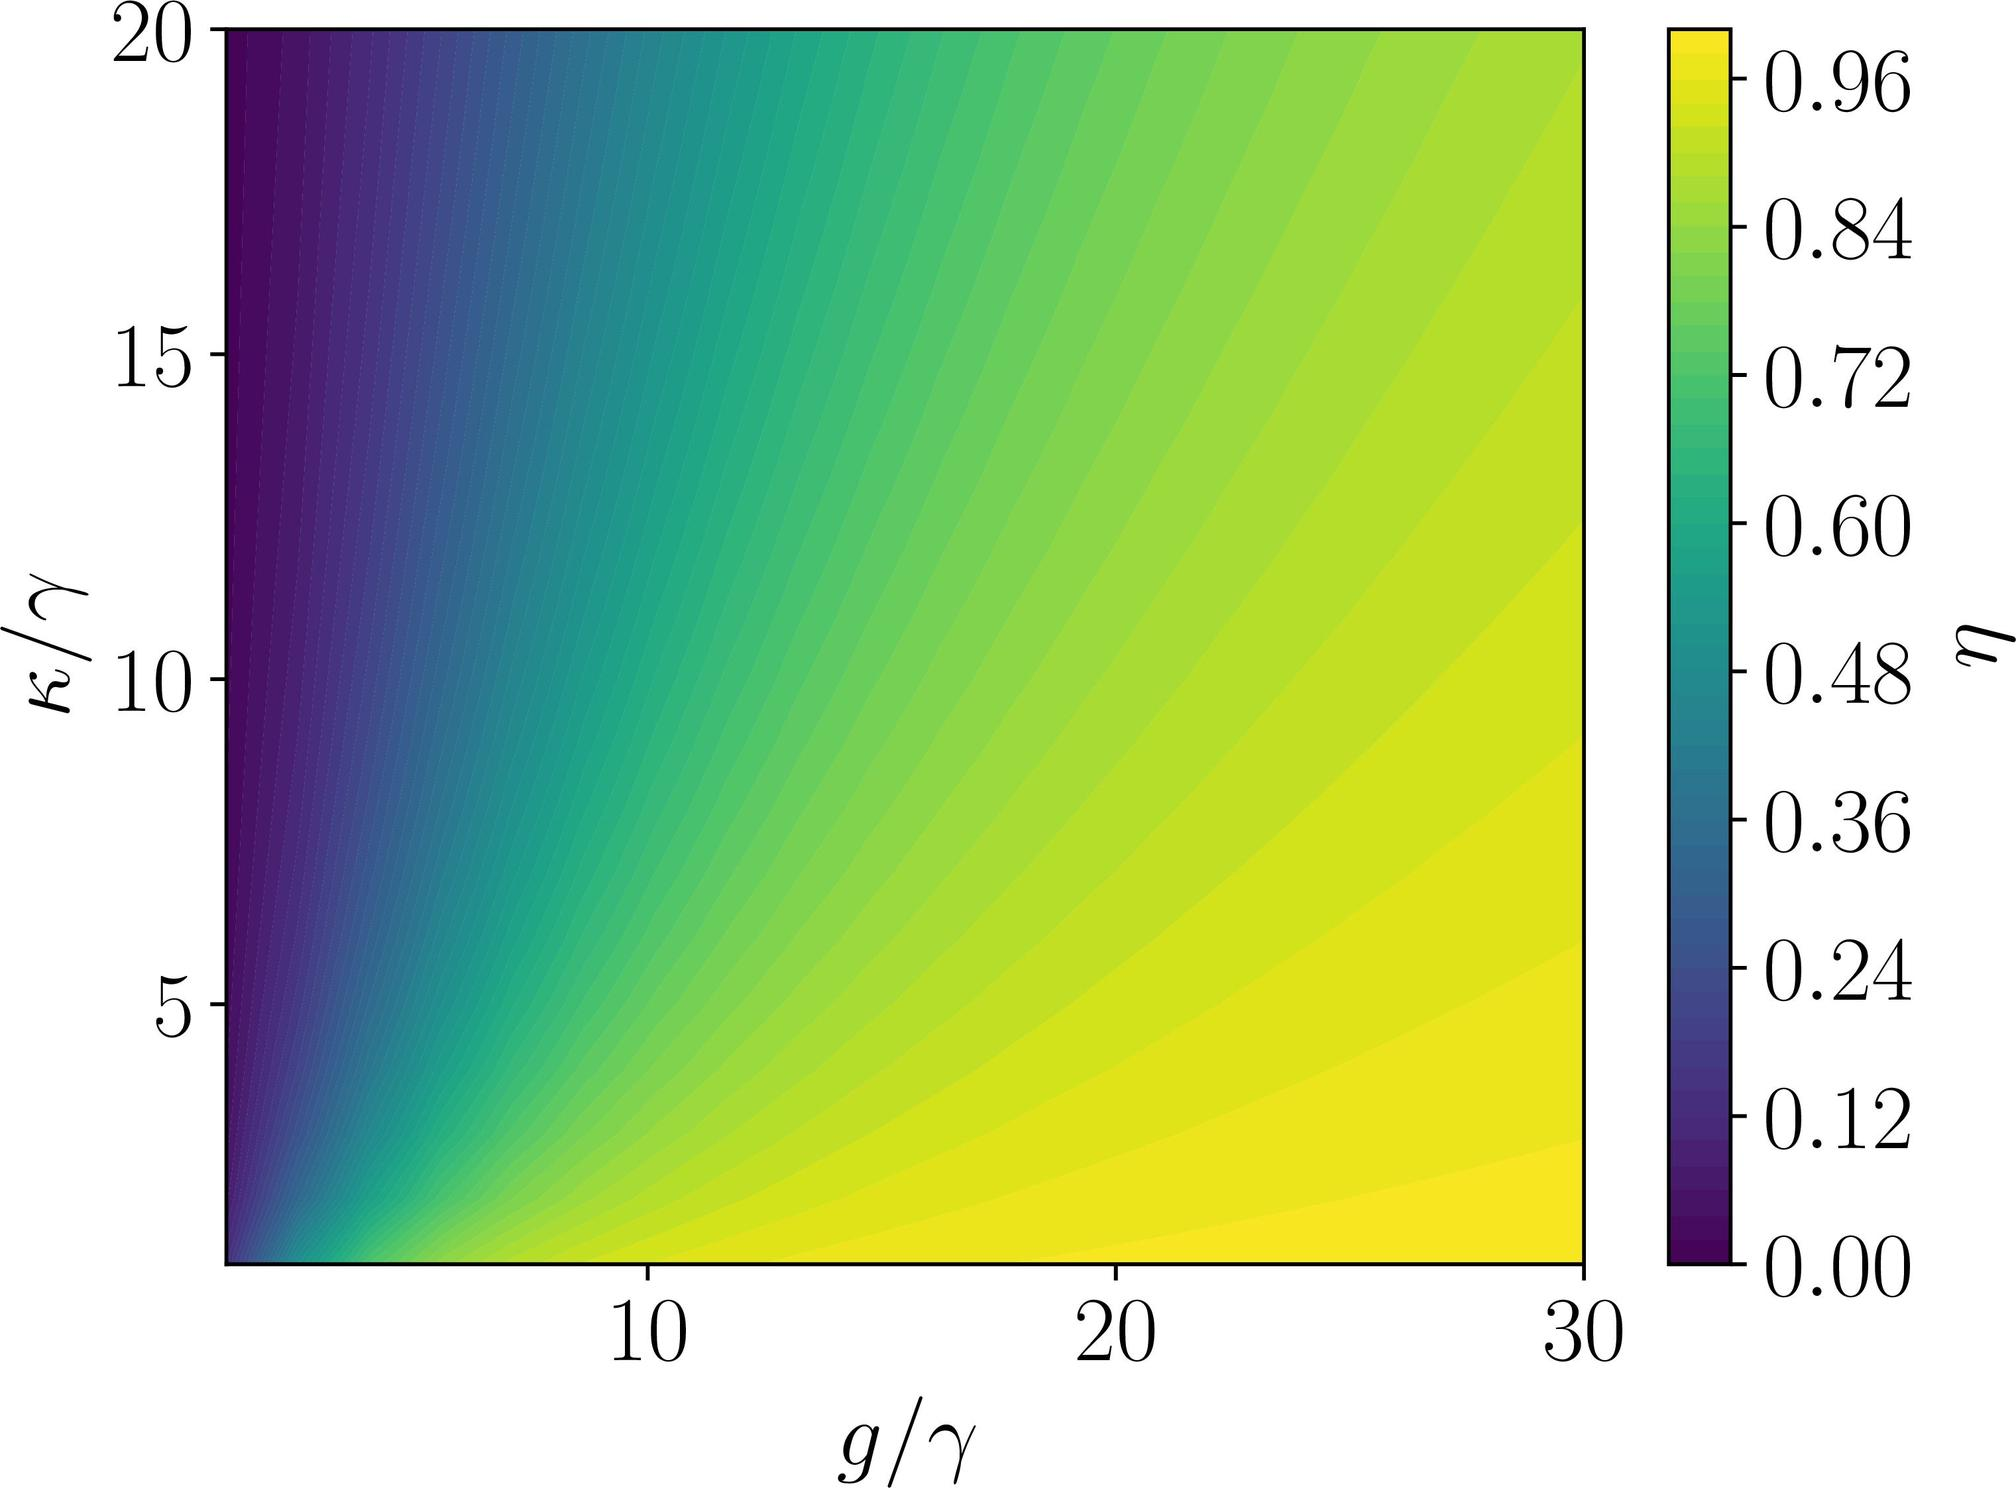Can you explain what the axes on this graph represent? Certainly! The graph presented is a contour plot, which is commonly used to visualize 3D surfaces in two dimensions. The horizontal axis labeled \( g/\gamma \) likely represents the ratio of a parameter 'g' to a parameter 'γ', whereas the vertical axis labeled \( \kappa/\gamma \) suggests the ratio of a different parameter 'κ' to 'γ'. The color gradient indicates the value of another variable \( \eta \), according to the color bar on the right-hand side. 